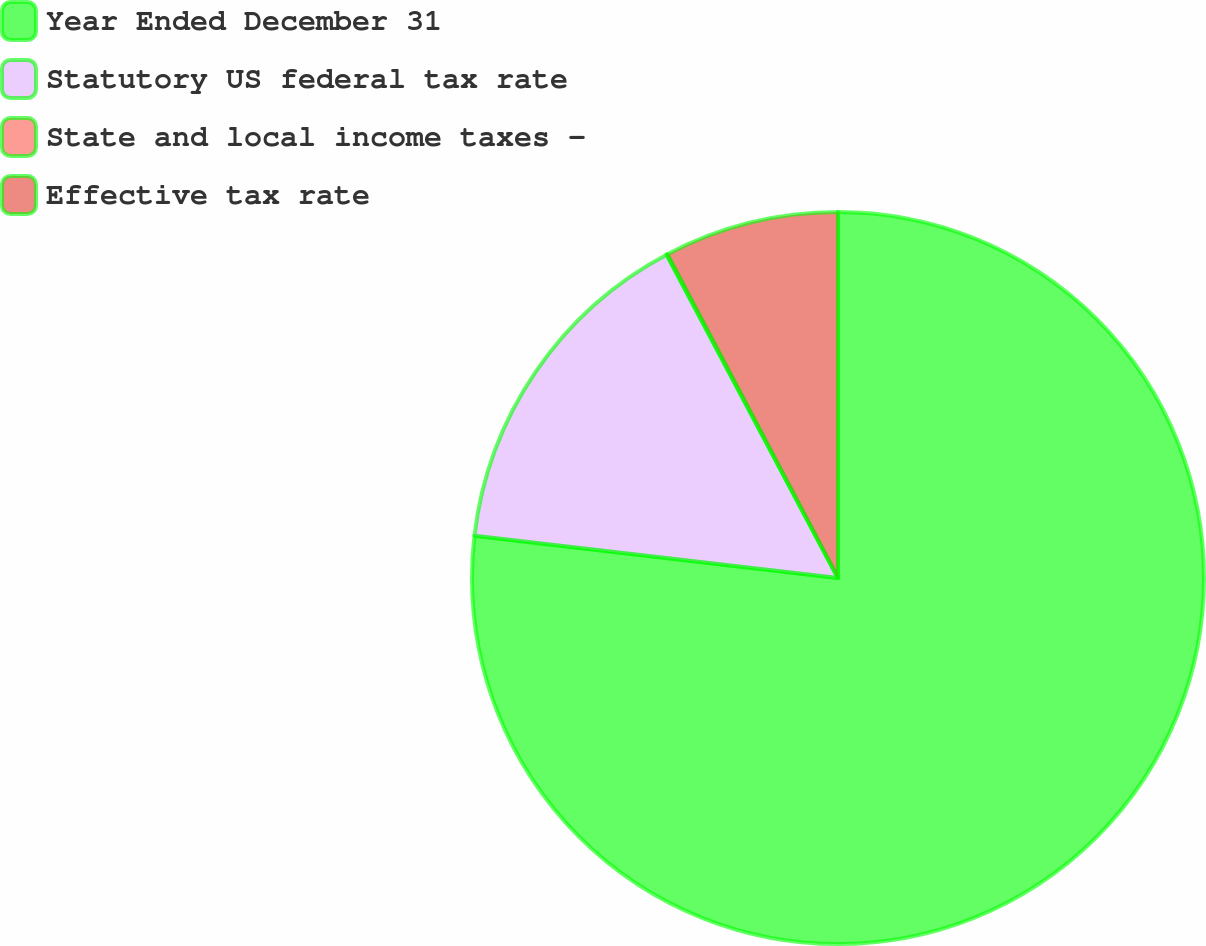Convert chart to OTSL. <chart><loc_0><loc_0><loc_500><loc_500><pie_chart><fcel>Year Ended December 31<fcel>Statutory US federal tax rate<fcel>State and local income taxes -<fcel>Effective tax rate<nl><fcel>76.84%<fcel>15.4%<fcel>0.04%<fcel>7.72%<nl></chart> 